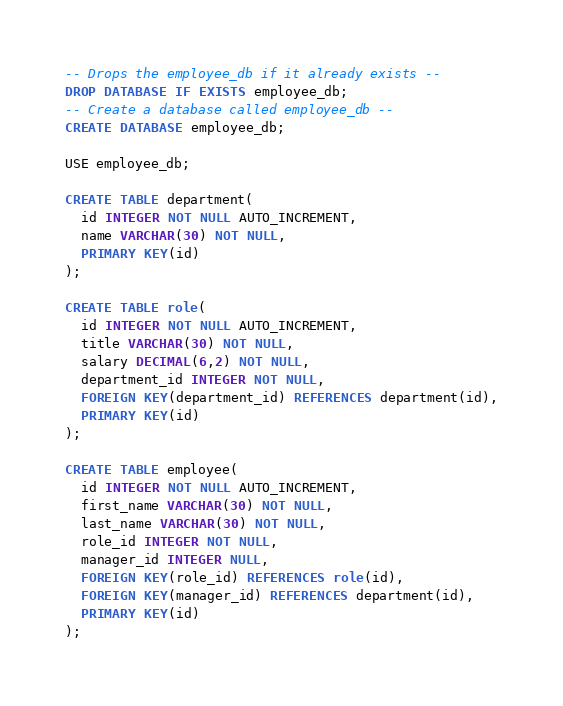Convert code to text. <code><loc_0><loc_0><loc_500><loc_500><_SQL_>-- Drops the employee_db if it already exists --
DROP DATABASE IF EXISTS employee_db;
-- Create a database called employee_db --
CREATE DATABASE employee_db;

USE employee_db;

CREATE TABLE department(
  id INTEGER NOT NULL AUTO_INCREMENT,
  name VARCHAR(30) NOT NULL,
  PRIMARY KEY(id)
);

CREATE TABLE role(
  id INTEGER NOT NULL AUTO_INCREMENT,
  title VARCHAR(30) NOT NULL,
  salary DECIMAL(6,2) NOT NULL,
  department_id INTEGER NOT NULL,
  FOREIGN KEY(department_id) REFERENCES department(id),
  PRIMARY KEY(id)
);

CREATE TABLE employee(
  id INTEGER NOT NULL AUTO_INCREMENT,
  first_name VARCHAR(30) NOT NULL,
  last_name VARCHAR(30) NOT NULL,
  role_id INTEGER NOT NULL,
  manager_id INTEGER NULL,
  FOREIGN KEY(role_id) REFERENCES role(id),
  FOREIGN KEY(manager_id) REFERENCES department(id),
  PRIMARY KEY(id)
);</code> 